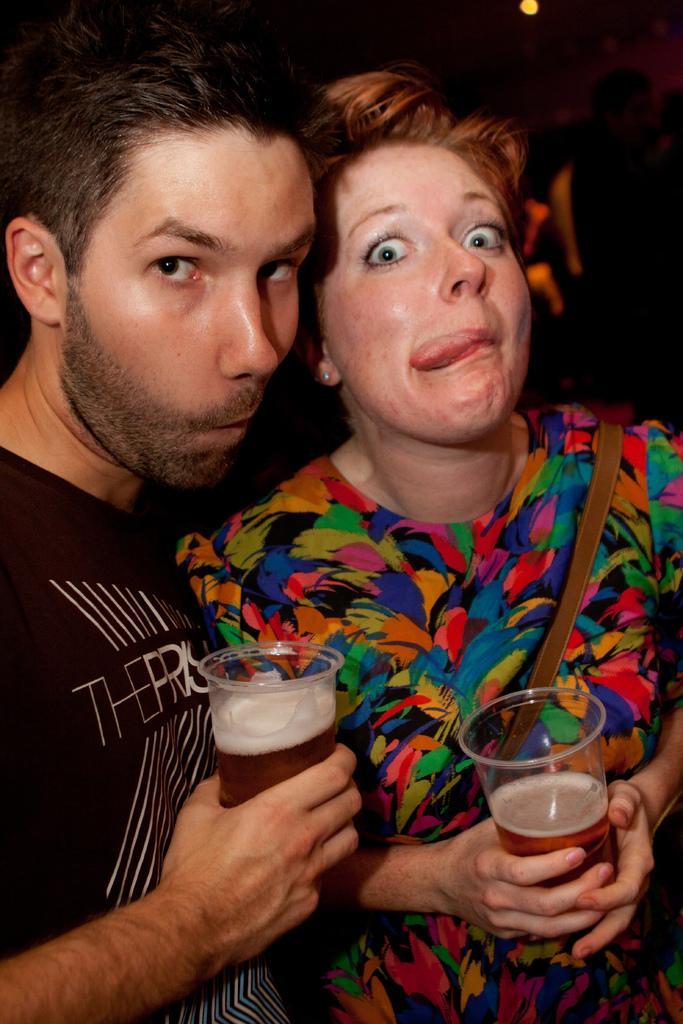Describe this image in one or two sentences. The man on the left corner of this picture wearing black t-shirt is holding a glass with beer in his hands and woman on the right side of the picture also holding a glass with wine or beer in her hands. She is wearing backpack and she is wearing a colorful dress. I think this photo is clicked in bar. 